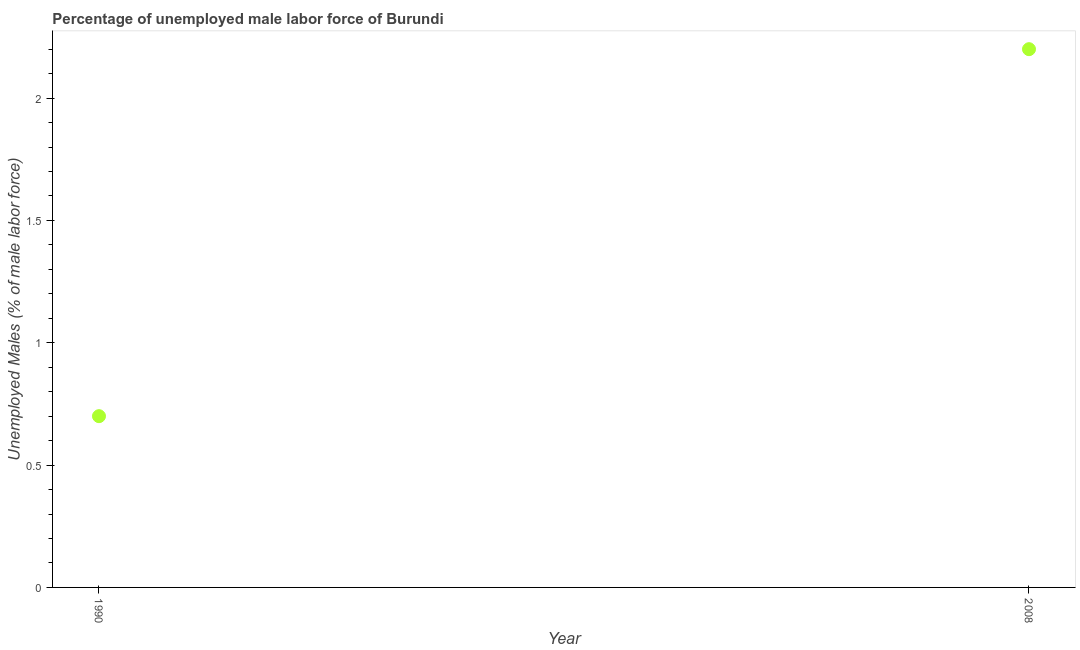What is the total unemployed male labour force in 2008?
Provide a succinct answer. 2.2. Across all years, what is the maximum total unemployed male labour force?
Your answer should be very brief. 2.2. Across all years, what is the minimum total unemployed male labour force?
Provide a short and direct response. 0.7. In which year was the total unemployed male labour force maximum?
Provide a succinct answer. 2008. What is the sum of the total unemployed male labour force?
Provide a succinct answer. 2.9. What is the difference between the total unemployed male labour force in 1990 and 2008?
Make the answer very short. -1.5. What is the average total unemployed male labour force per year?
Make the answer very short. 1.45. What is the median total unemployed male labour force?
Provide a short and direct response. 1.45. In how many years, is the total unemployed male labour force greater than 1 %?
Provide a short and direct response. 1. What is the ratio of the total unemployed male labour force in 1990 to that in 2008?
Your response must be concise. 0.32. Is the total unemployed male labour force in 1990 less than that in 2008?
Provide a short and direct response. Yes. In how many years, is the total unemployed male labour force greater than the average total unemployed male labour force taken over all years?
Provide a short and direct response. 1. What is the difference between two consecutive major ticks on the Y-axis?
Ensure brevity in your answer.  0.5. Are the values on the major ticks of Y-axis written in scientific E-notation?
Offer a terse response. No. Does the graph contain any zero values?
Provide a succinct answer. No. What is the title of the graph?
Your answer should be compact. Percentage of unemployed male labor force of Burundi. What is the label or title of the X-axis?
Your answer should be compact. Year. What is the label or title of the Y-axis?
Make the answer very short. Unemployed Males (% of male labor force). What is the Unemployed Males (% of male labor force) in 1990?
Provide a succinct answer. 0.7. What is the Unemployed Males (% of male labor force) in 2008?
Ensure brevity in your answer.  2.2. What is the ratio of the Unemployed Males (% of male labor force) in 1990 to that in 2008?
Keep it short and to the point. 0.32. 